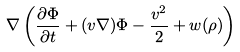Convert formula to latex. <formula><loc_0><loc_0><loc_500><loc_500>\nabla \left ( \frac { \partial \Phi } { \partial t } + ( { v } \nabla ) \Phi - \frac { { v } ^ { 2 } } { 2 } + w ( \rho ) \right )</formula> 